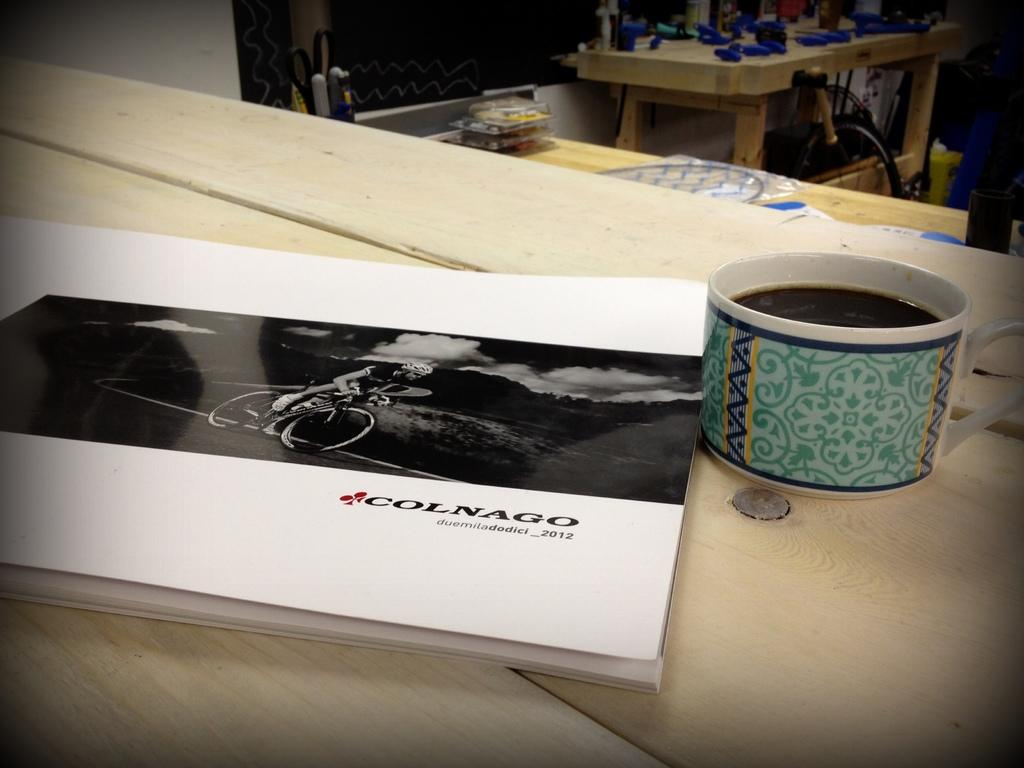What objects can be seen on the table in the image? There are scissors, markers, a box, a book, and a cup of drink on the table in the image. What might be used for cutting in the image? Scissors can be used for cutting in the image. What might be used for drawing or coloring in the image? Markers can be used for drawing or coloring in the image. What might be used for holding or storing items in the image? The box can be used for holding or storing items in the image. What might be used for reading in the image? The book can be used for reading in the image. What might be used for drinking in the image? The cup of drink can be used for drinking in the image. How many frogs are sitting on the table in the image? There are no frogs present on the table in the image. What type of badge can be seen on the book in the image? There is no badge present on the book in the image. 